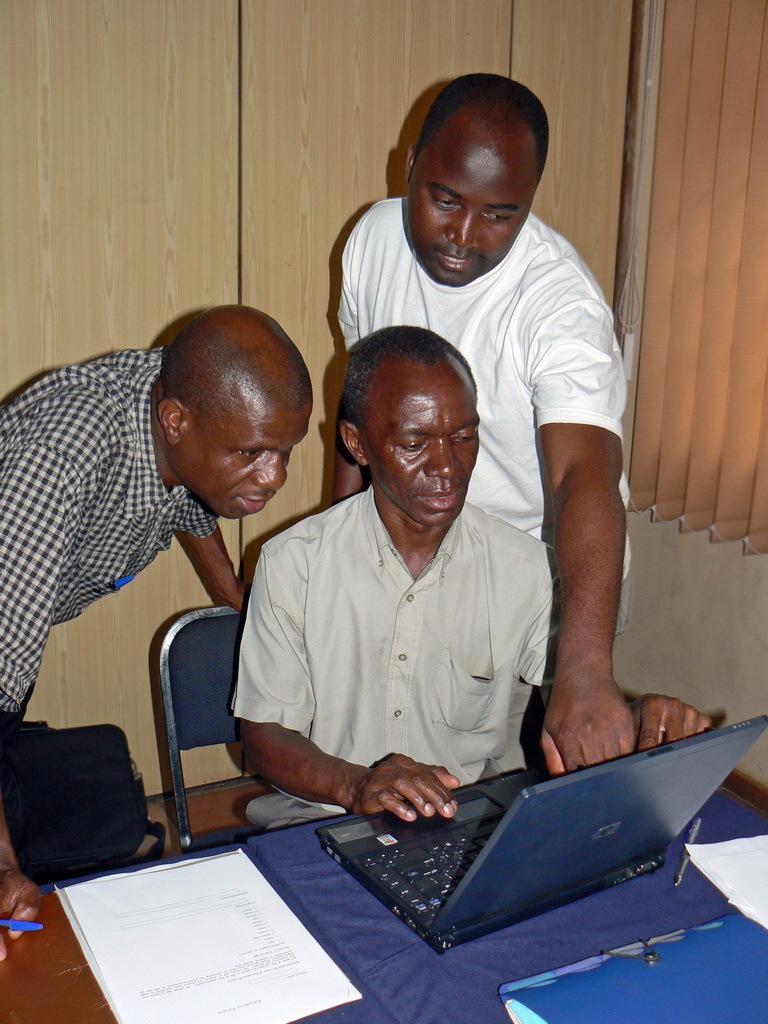Please provide a concise description of this image. This picture show three people one man is sitting on the chair and using a laptop and other two are standing. And watching the laptop. 